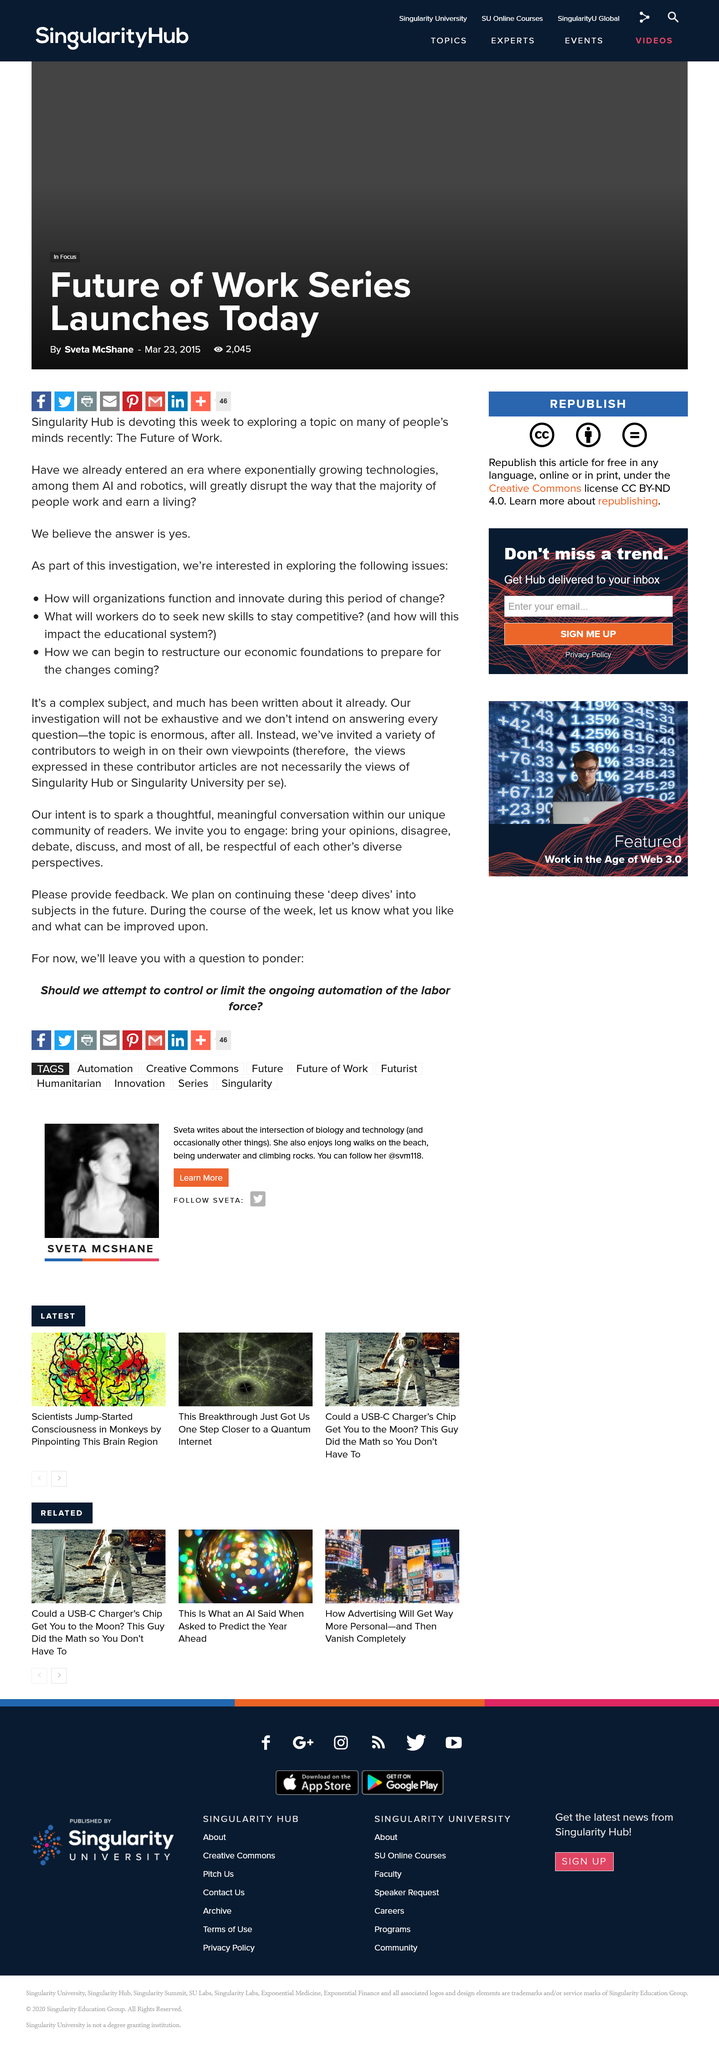Identify some key points in this picture. The topic is enormous. Singularity Hub launched the series. The series was launched in 2015. 